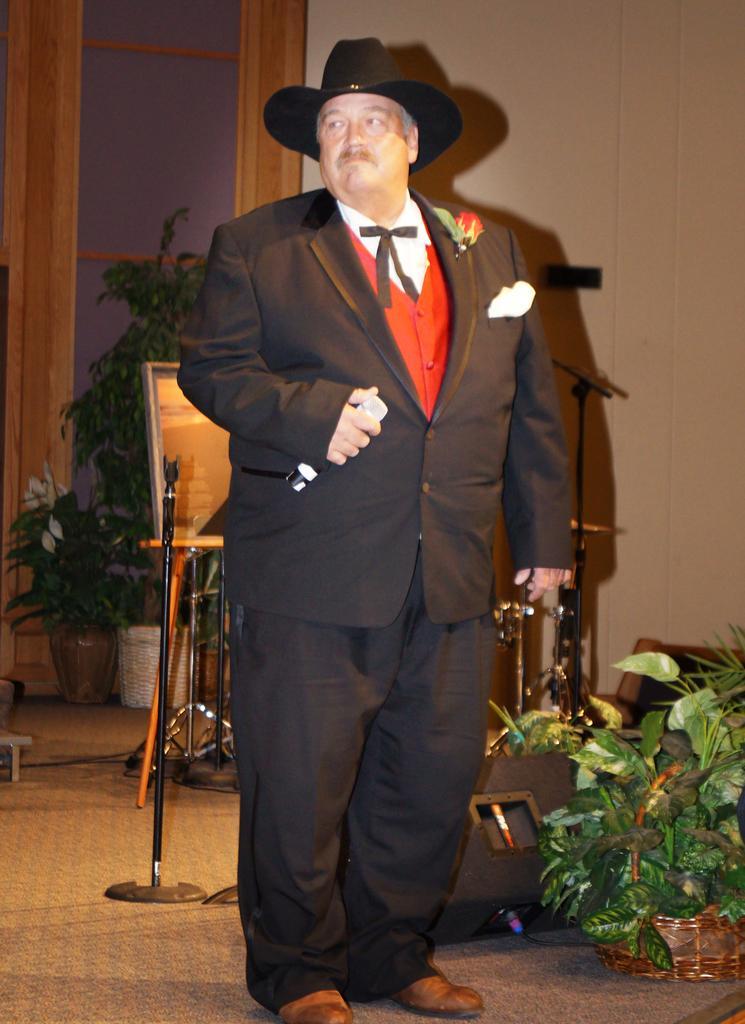Can you describe this image briefly? In this picture a man in black blazer with hat holding a microphone. Background of this man is a wall and a glass window. To the right side of the man there are the flower pots. 